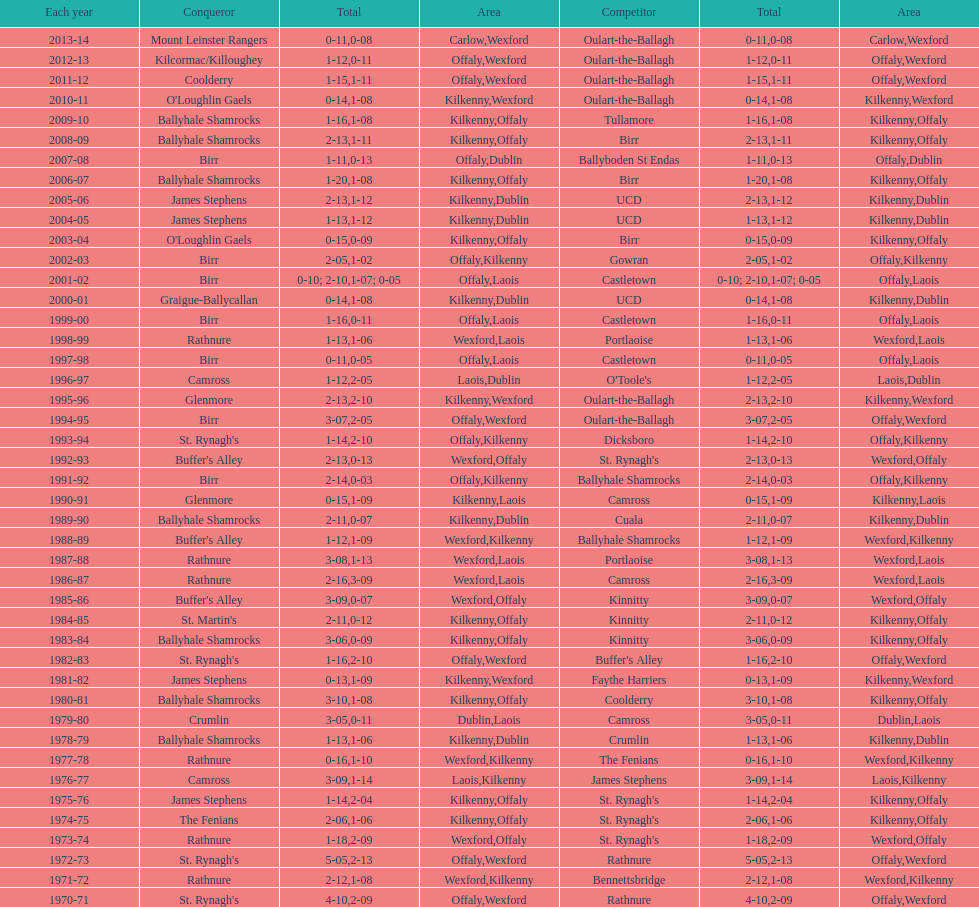Which team won the leinster senior club hurling championships previous to the last time birr won? Ballyhale Shamrocks. 